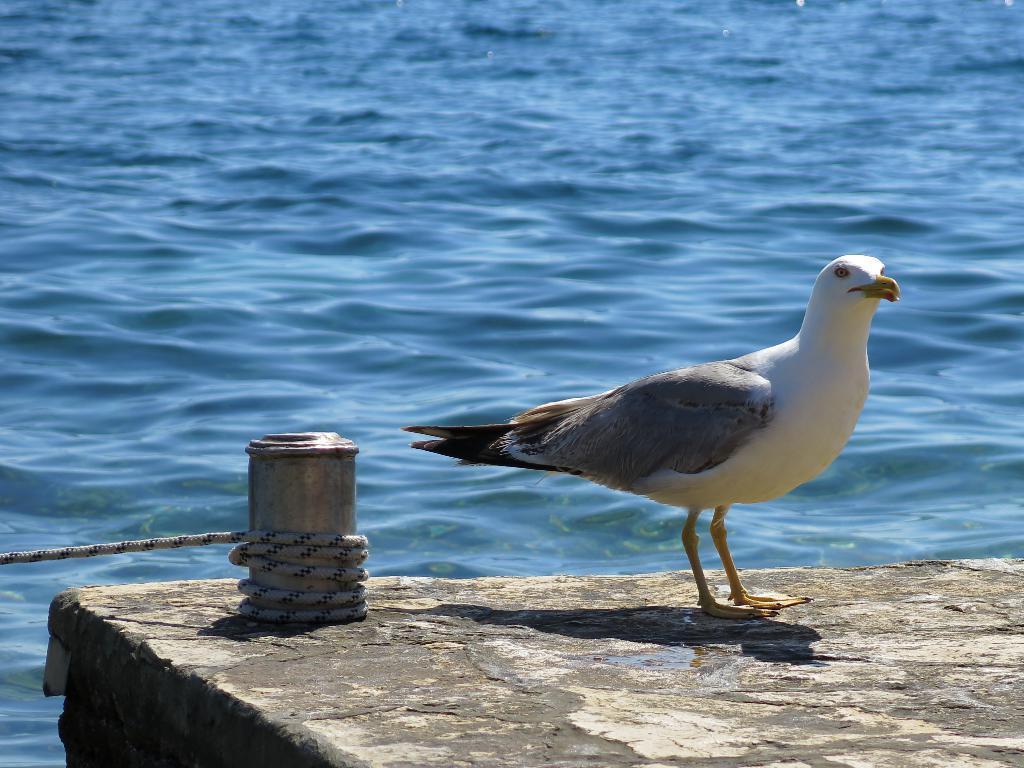Can you describe this image briefly? In the center of the image we can see one stone. On the stone, we can see one bird, which is in black and white color. And we can see one pole type object. And we can see one rope around the pole. In the background we can see water. 